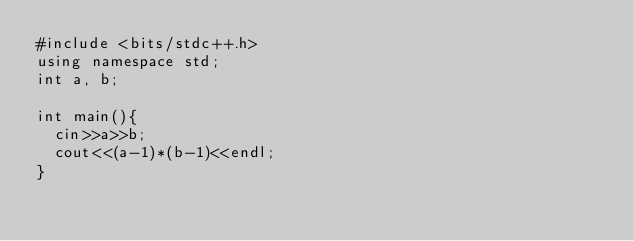<code> <loc_0><loc_0><loc_500><loc_500><_C++_>#include <bits/stdc++.h>
using namespace std;
int a, b;

int main(){
  cin>>a>>b;
  cout<<(a-1)*(b-1)<<endl;
}</code> 